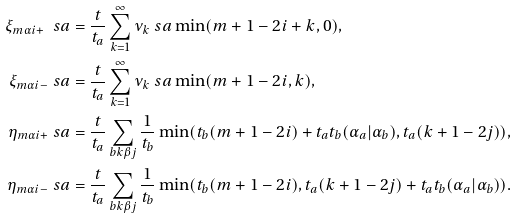<formula> <loc_0><loc_0><loc_500><loc_500>\xi _ { m \alpha i + } \ s a & = \frac { t } { t _ { a } } \sum _ { k = 1 } ^ { \infty } { \nu _ { k } \ s a } \min ( m + 1 - 2 i + k , 0 ) , \\ \xi _ { m \alpha i - } \ s a & = \frac { t } { t _ { a } } \sum _ { k = 1 } ^ { \infty } { \nu _ { k } \ s a } \min ( m + 1 - 2 i , k ) , \\ \eta _ { m \alpha i + } \ s a & = \frac { t } { t _ { a } } \sum _ { b k \beta j } \frac { 1 } { t _ { b } } \min ( t _ { b } ( m + 1 - 2 i ) + t _ { a } t _ { b } ( \alpha _ { a } | \alpha _ { b } ) , t _ { a } ( k + 1 - 2 j ) ) , \\ \eta _ { m \alpha i - } \ s a & = \frac { t } { t _ { a } } \sum _ { b k \beta j } \frac { 1 } { t _ { b } } \min ( t _ { b } ( m + 1 - 2 i ) , t _ { a } ( k + 1 - 2 j ) + t _ { a } t _ { b } ( \alpha _ { a } | \alpha _ { b } ) ) .</formula> 